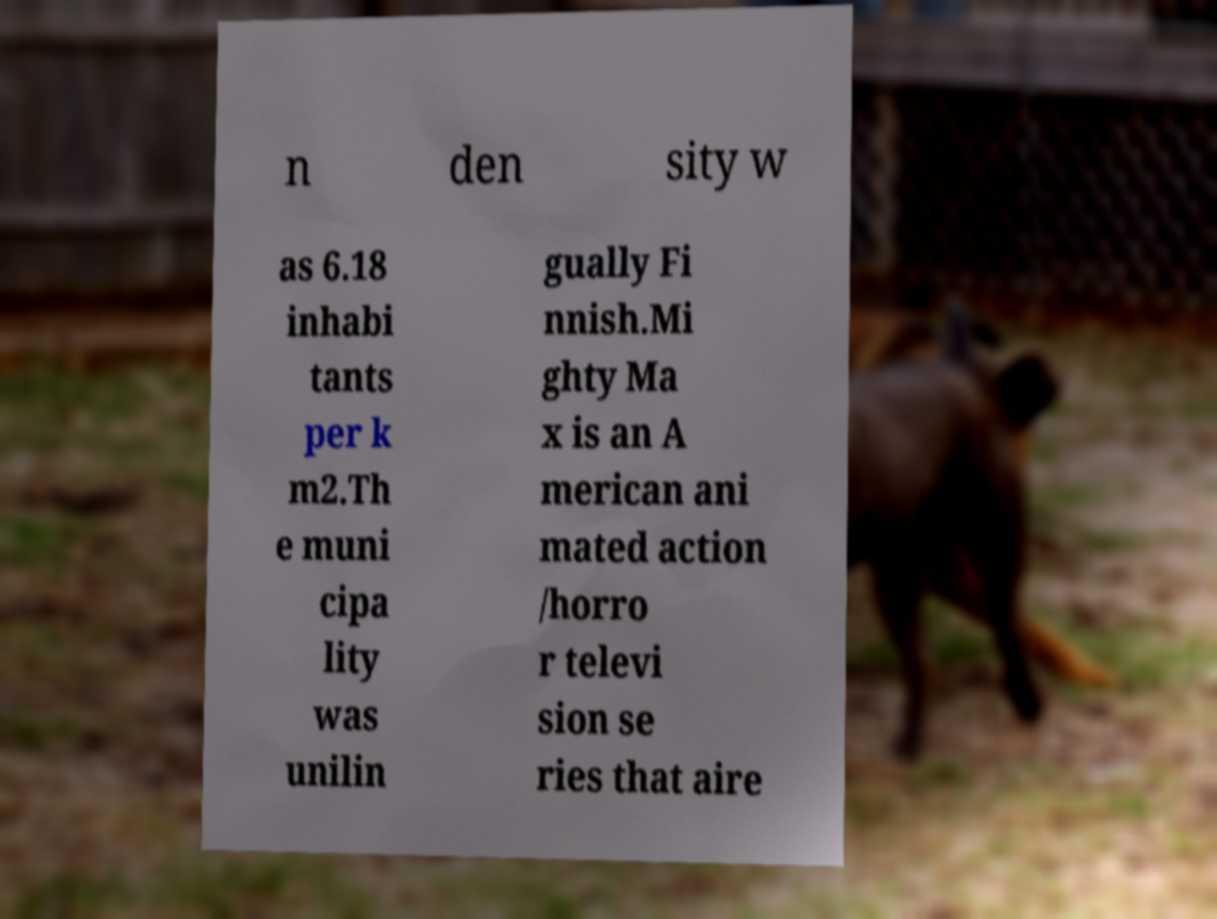Could you extract and type out the text from this image? n den sity w as 6.18 inhabi tants per k m2.Th e muni cipa lity was unilin gually Fi nnish.Mi ghty Ma x is an A merican ani mated action /horro r televi sion se ries that aire 